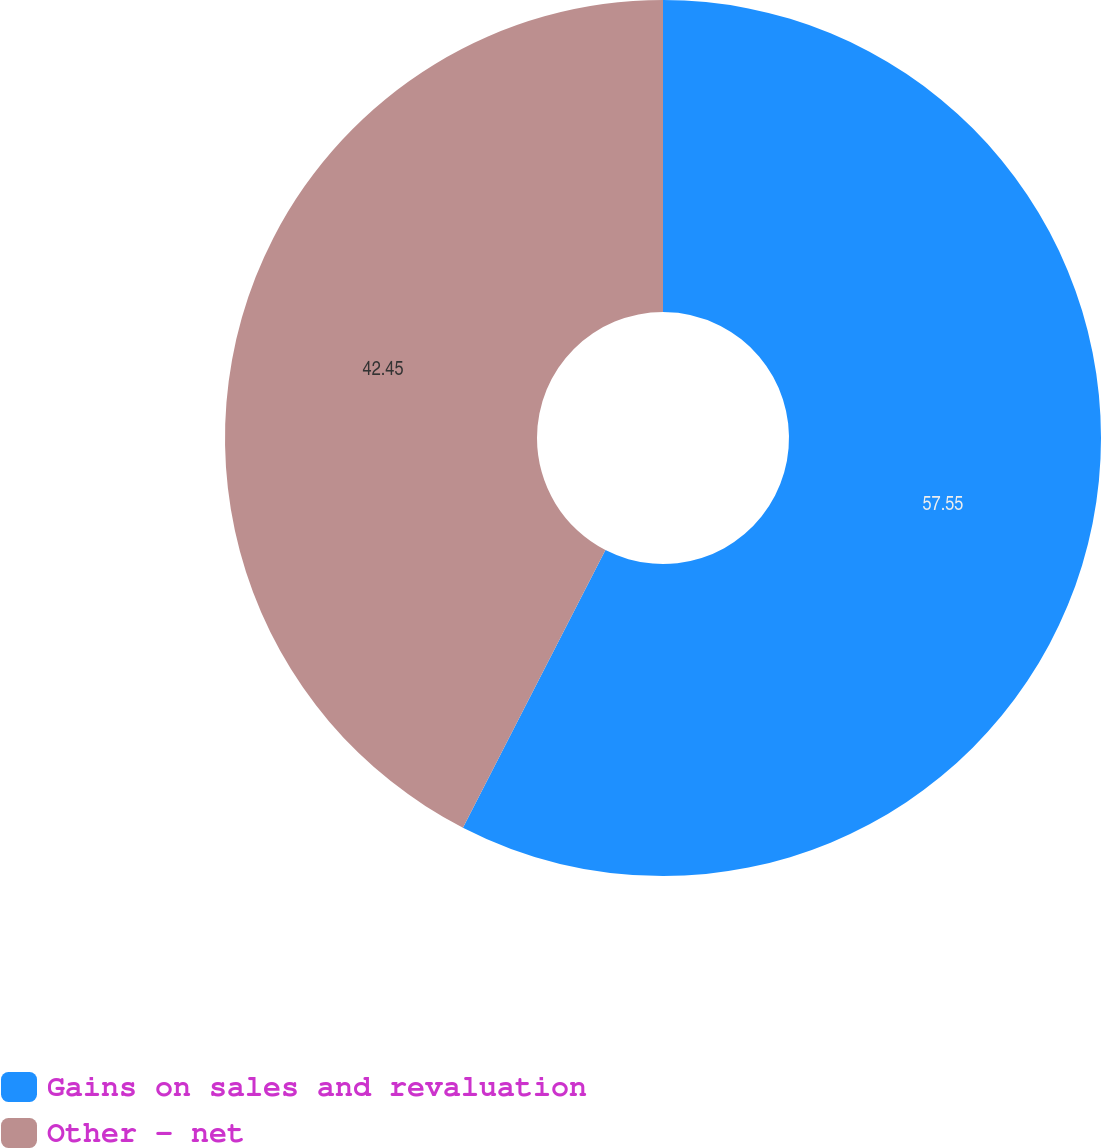Convert chart. <chart><loc_0><loc_0><loc_500><loc_500><pie_chart><fcel>Gains on sales and revaluation<fcel>Other - net<nl><fcel>57.55%<fcel>42.45%<nl></chart> 